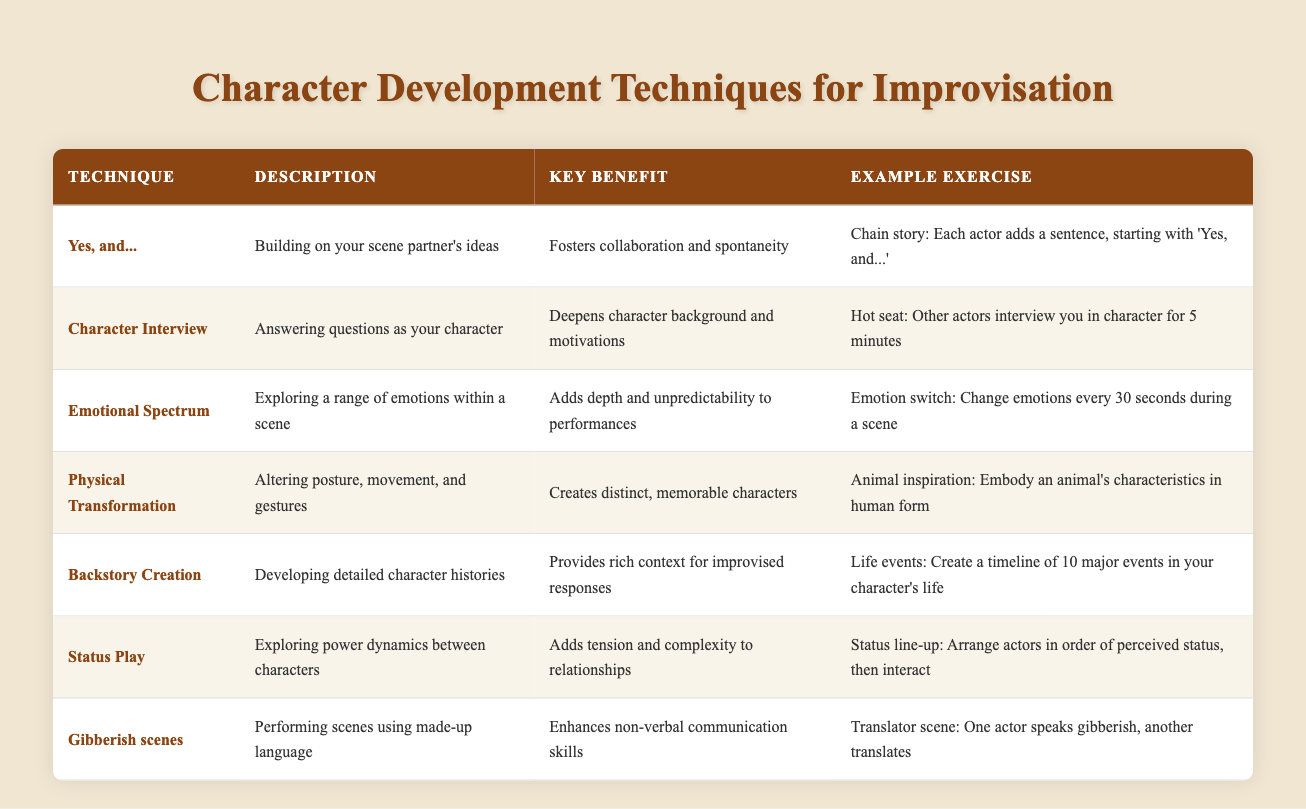What is the key benefit of using the "Yes, and..." technique? The table states that the key benefit of using the "Yes, and..." technique is that it fosters collaboration and spontaneity.
Answer: Fosters collaboration and spontaneity Which technique involves exploring power dynamics between characters? The table shows that "Status Play" involves exploring power dynamics between characters.
Answer: Status Play How many techniques have emotional exploration in their descriptions? Looking at the table, "Emotional Spectrum" discusses emotional exploration, while multiple techniques may contribute to a scene's emotional depth, but they don't explicitly mention it. Thus, only one technique specifically focuses on emotional exploration.
Answer: 1 Is "Gibberish scenes" aimed at enhancing verbal communication skills? According to the table, "Gibberish scenes" enhances non-verbal communication skills, not verbal. Therefore, the statement is false.
Answer: No Which example exercise is associated with "Backstory Creation"? The table clearly states that the example exercise for "Backstory Creation" is to create a timeline of 10 major events in your character's life.
Answer: Create a timeline of 10 major events in your character's life What is the combined key benefit of "Character Interview" and "Backstory Creation"? The key benefit for "Character Interview" is deepening character background and motivations, while for "Backstory Creation," it's providing rich context for improvised responses. Combining these benefits suggests that they both enrich character authenticity and depth in performance contexts.
Answer: Deepens character background and provides rich context Which technique allows for a shift in emotions every 30 seconds during a scene? The table notes that the "Emotion switch" exercise is meant for the "Emotional Spectrum" technique and allows for the shift of emotions every 30 seconds.
Answer: Emotional Spectrum What is the relationship between "Physical Transformation" and the creation of distinct characters? The table connects "Physical Transformation" to the creation of distinct, memorable characters, showing that altering posture, movement, and gestures helps actors embody unique traits.
Answer: Creates distinct, memorable characters Which two techniques focus on enhancing communication within a scene? "Yes, and..." and "Gibberish scenes" both emphasize communication—collaboration in the first and non-verbal cues in the latter. Therefore, both enhance communication dynamics in performance.
Answer: Yes, and... & Gibberish scenes 